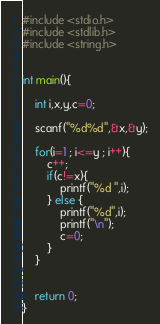Convert code to text. <code><loc_0><loc_0><loc_500><loc_500><_C++_>#include <stdio.h>
#include <stdlib.h>
#include <string.h>


int main(){

    int i,x,y,c=0;

    scanf("%d%d",&x,&y);

    for(i=1 ; i<=y ; i++){
        c++;
        if(c!=x){
            printf("%d ",i);
        } else {
            printf("%d",i);
            printf("\n");
            c=0;
        }
    }


    return 0;
}
</code> 